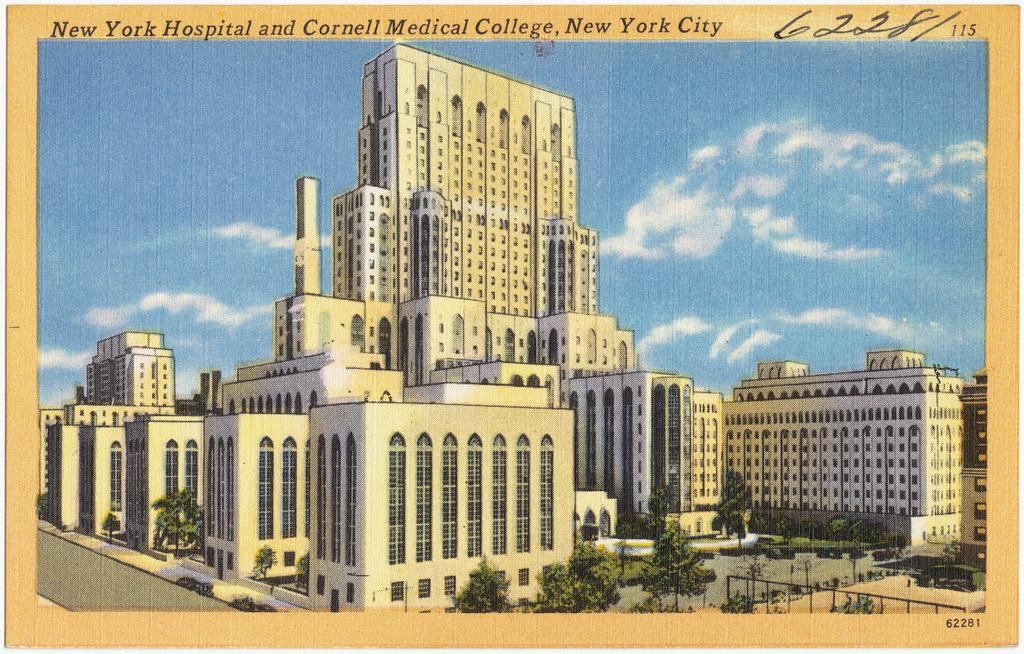What is depicted in the image on the poster? The image on the poster contains buildings, trees, and roads. What can be seen in the sky in the image? There are clouds in the sky in the image. What is present on the poster besides the image? There are texts on the poster. How is the poster visually distinguished from the background? The poster has a border. What type of glass can be seen in the image? There is no glass present in the image; it contains buildings, trees, roads, clouds, texts, and a border. 